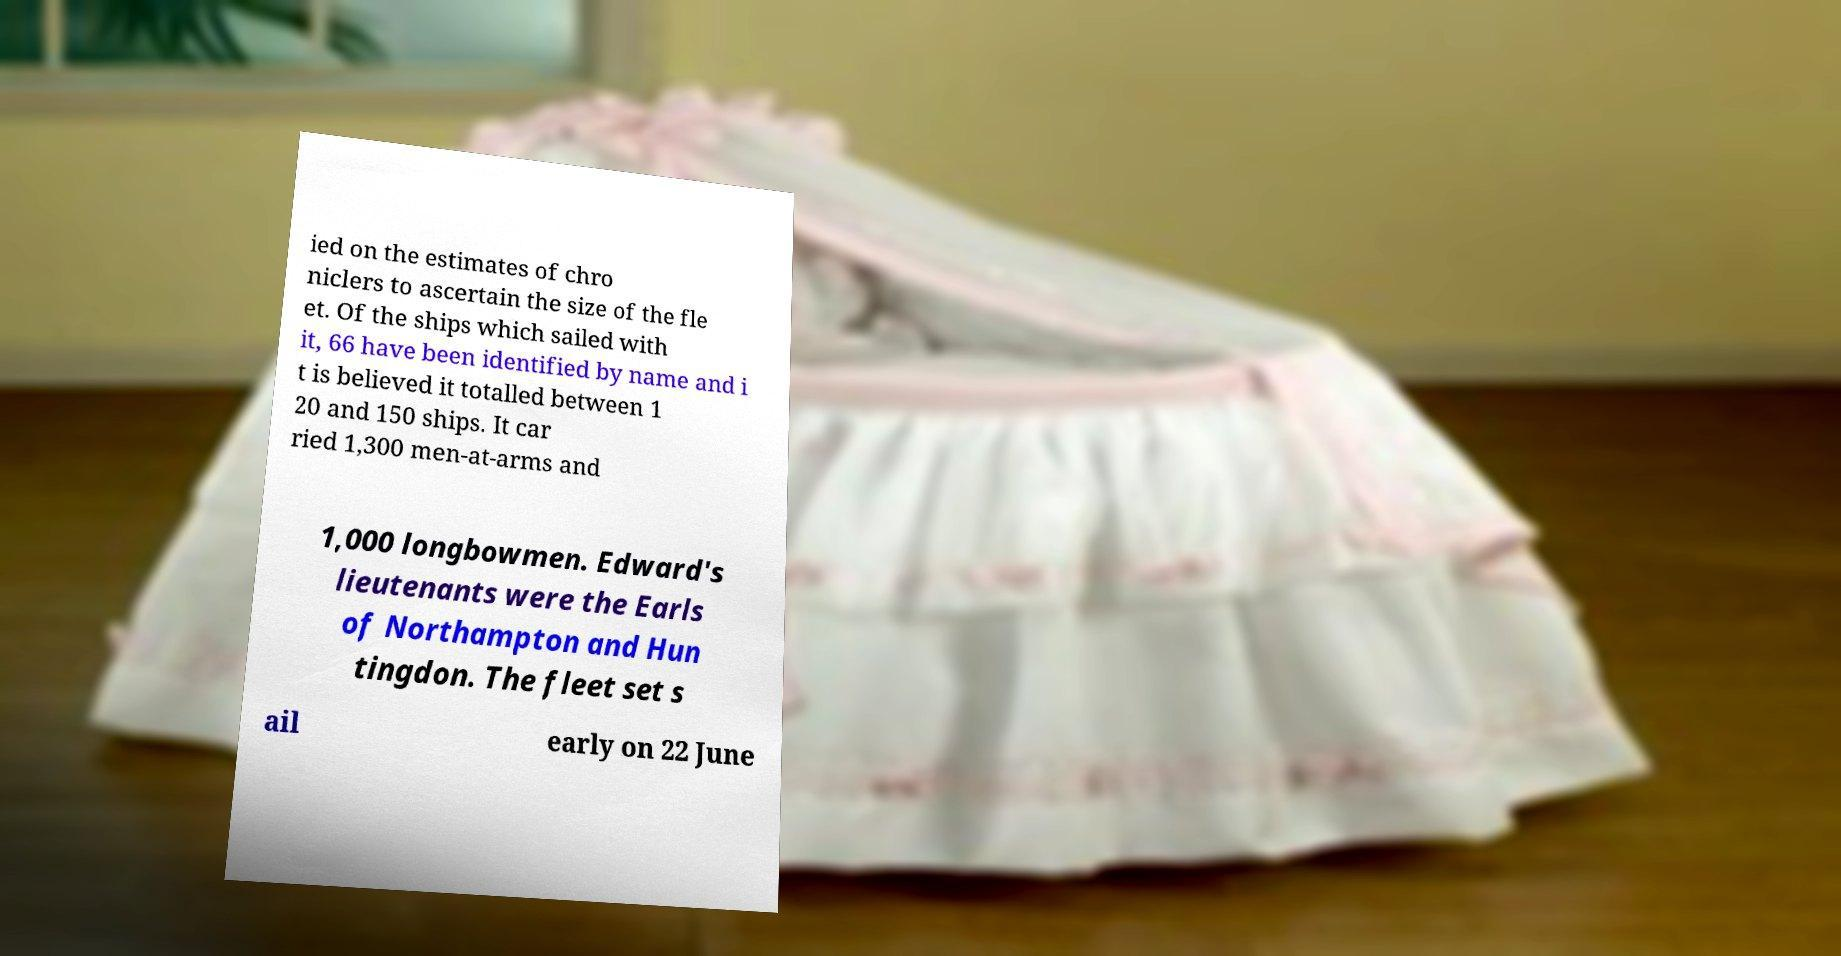Can you read and provide the text displayed in the image?This photo seems to have some interesting text. Can you extract and type it out for me? ied on the estimates of chro niclers to ascertain the size of the fle et. Of the ships which sailed with it, 66 have been identified by name and i t is believed it totalled between 1 20 and 150 ships. It car ried 1,300 men-at-arms and 1,000 longbowmen. Edward's lieutenants were the Earls of Northampton and Hun tingdon. The fleet set s ail early on 22 June 